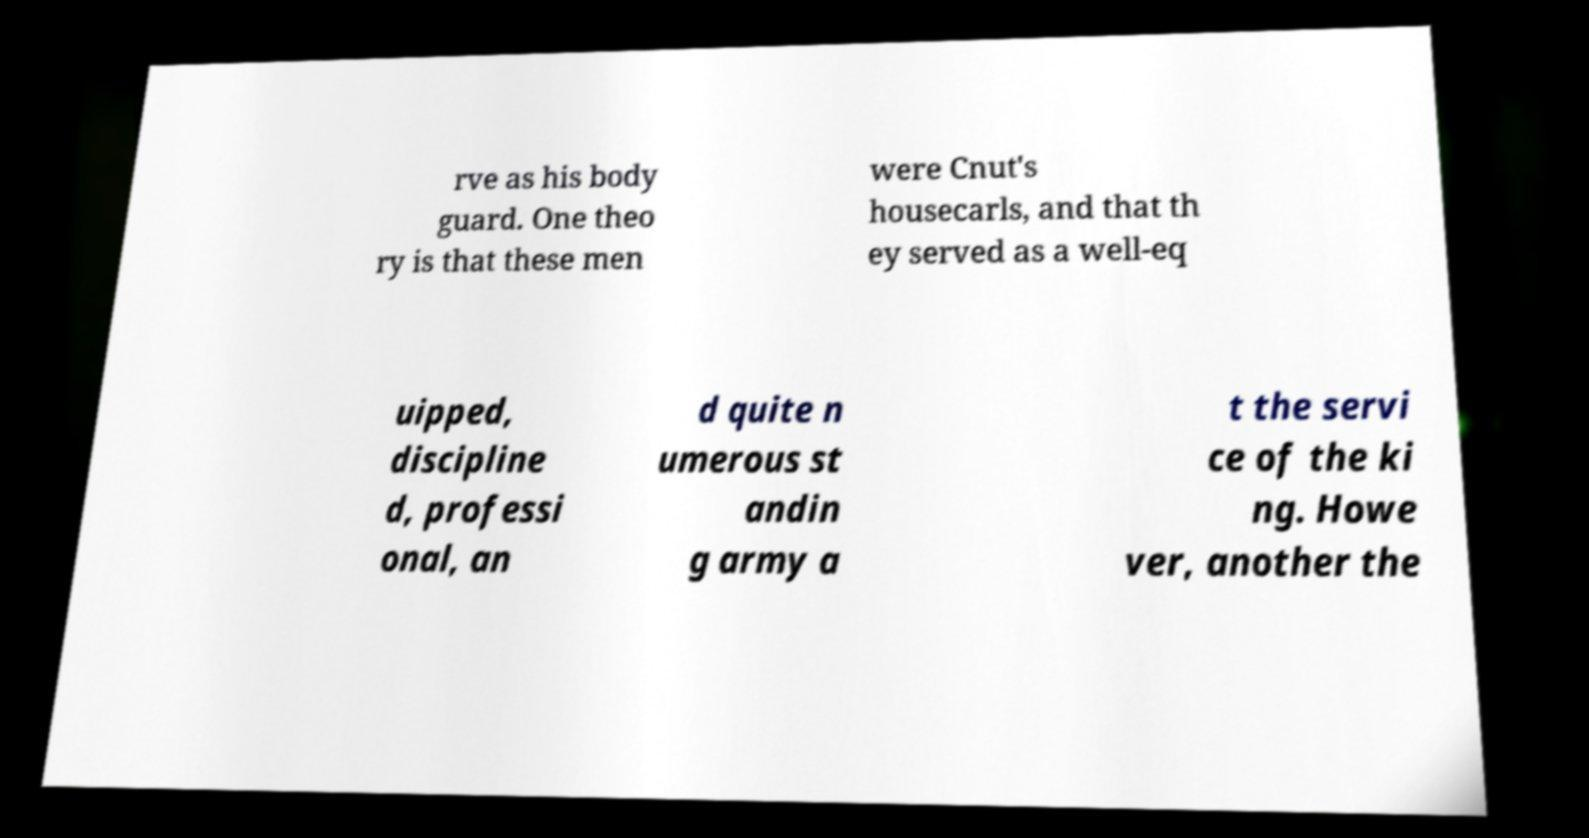Please read and relay the text visible in this image. What does it say? rve as his body guard. One theo ry is that these men were Cnut's housecarls, and that th ey served as a well-eq uipped, discipline d, professi onal, an d quite n umerous st andin g army a t the servi ce of the ki ng. Howe ver, another the 